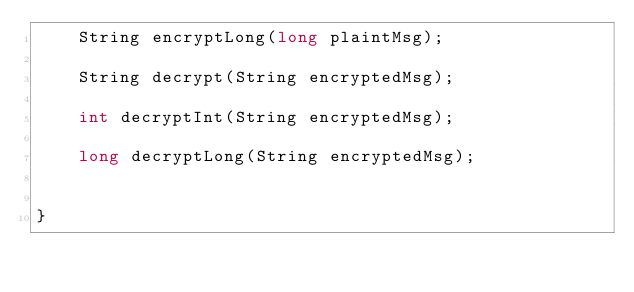<code> <loc_0><loc_0><loc_500><loc_500><_Java_>    String encryptLong(long plaintMsg);

    String decrypt(String encryptedMsg);

    int decryptInt(String encryptedMsg);

    long decryptLong(String encryptedMsg);


}
</code> 